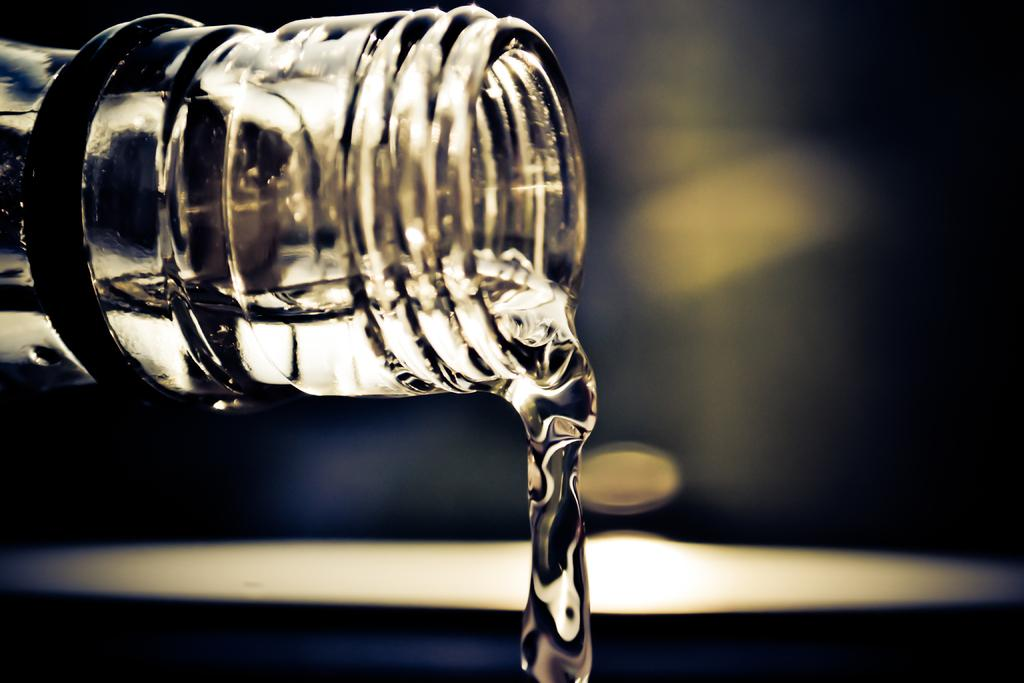What is the main subject of the image? The main subject of the image is a flow of water. Where is the water coming from? The water is flowing from a bottle. What type of stocking can be seen at the seashore in the image? There is no stocking or seashore present in the image; it only features a flow of water coming from a bottle. 